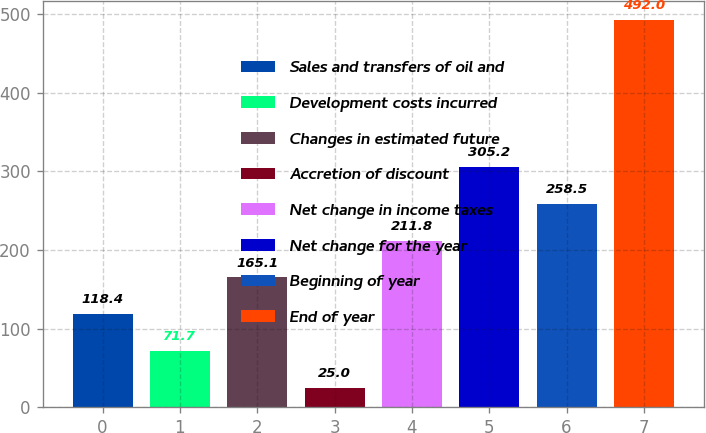<chart> <loc_0><loc_0><loc_500><loc_500><bar_chart><fcel>Sales and transfers of oil and<fcel>Development costs incurred<fcel>Changes in estimated future<fcel>Accretion of discount<fcel>Net change in income taxes<fcel>Net change for the year<fcel>Beginning of year<fcel>End of year<nl><fcel>118.4<fcel>71.7<fcel>165.1<fcel>25<fcel>211.8<fcel>305.2<fcel>258.5<fcel>492<nl></chart> 